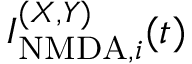Convert formula to latex. <formula><loc_0><loc_0><loc_500><loc_500>I _ { N M D A , i } ^ { ( X , Y ) } ( t )</formula> 